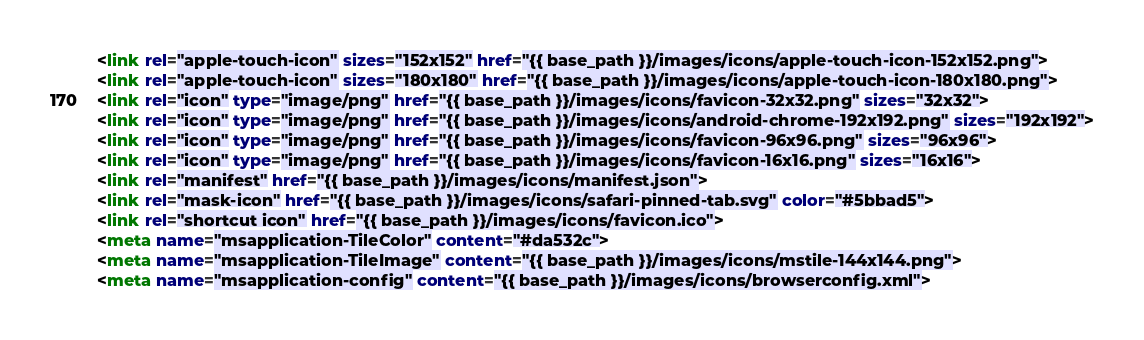Convert code to text. <code><loc_0><loc_0><loc_500><loc_500><_HTML_><link rel="apple-touch-icon" sizes="152x152" href="{{ base_path }}/images/icons/apple-touch-icon-152x152.png">
<link rel="apple-touch-icon" sizes="180x180" href="{{ base_path }}/images/icons/apple-touch-icon-180x180.png">
<link rel="icon" type="image/png" href="{{ base_path }}/images/icons/favicon-32x32.png" sizes="32x32">
<link rel="icon" type="image/png" href="{{ base_path }}/images/icons/android-chrome-192x192.png" sizes="192x192">
<link rel="icon" type="image/png" href="{{ base_path }}/images/icons/favicon-96x96.png" sizes="96x96">
<link rel="icon" type="image/png" href="{{ base_path }}/images/icons/favicon-16x16.png" sizes="16x16">
<link rel="manifest" href="{{ base_path }}/images/icons/manifest.json">
<link rel="mask-icon" href="{{ base_path }}/images/icons/safari-pinned-tab.svg" color="#5bbad5">
<link rel="shortcut icon" href="{{ base_path }}/images/icons/favicon.ico">
<meta name="msapplication-TileColor" content="#da532c">
<meta name="msapplication-TileImage" content="{{ base_path }}/images/icons/mstile-144x144.png">
<meta name="msapplication-config" content="{{ base_path }}/images/icons/browserconfig.xml"></code> 